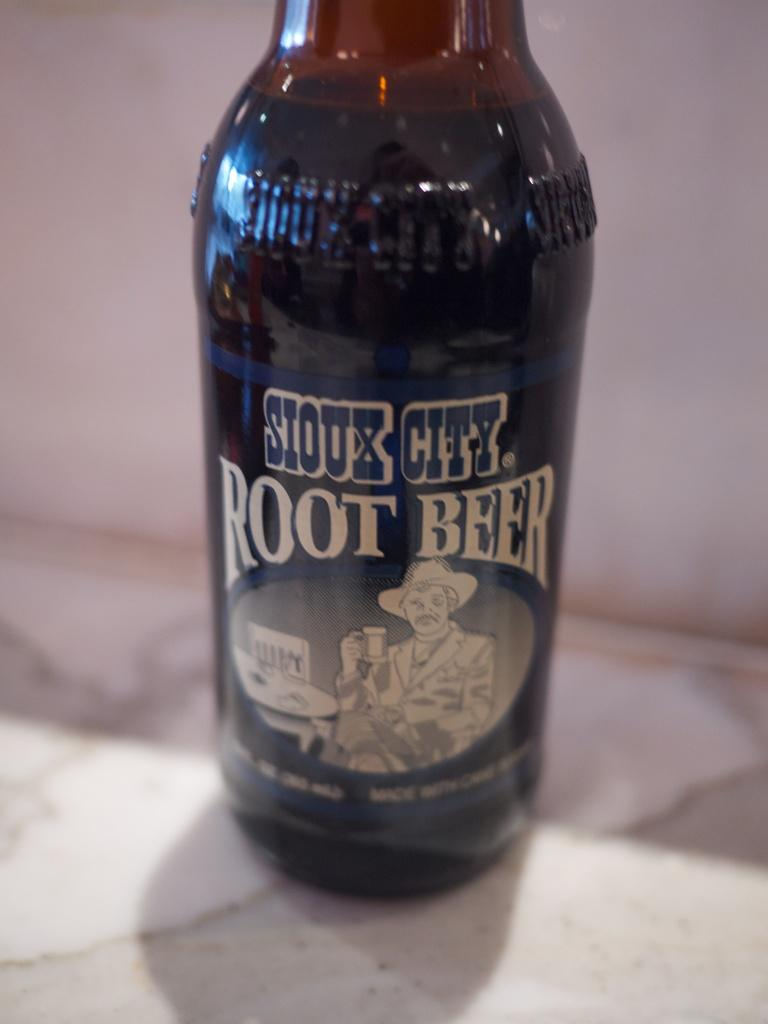<image>
Provide a brief description of the given image. A bottle of root beer with the name Sioux City on it 